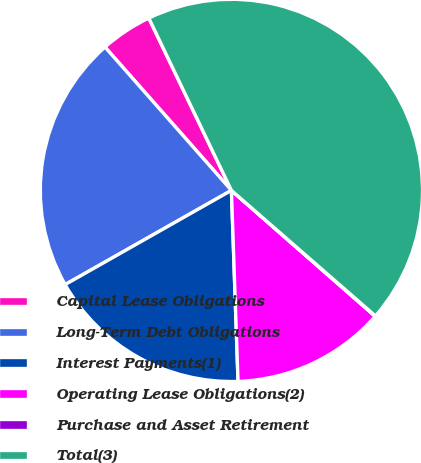<chart> <loc_0><loc_0><loc_500><loc_500><pie_chart><fcel>Capital Lease Obligations<fcel>Long-Term Debt Obligations<fcel>Interest Payments(1)<fcel>Operating Lease Obligations(2)<fcel>Purchase and Asset Retirement<fcel>Total(3)<nl><fcel>4.39%<fcel>21.7%<fcel>17.35%<fcel>13.0%<fcel>0.04%<fcel>43.53%<nl></chart> 